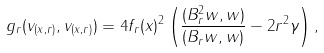Convert formula to latex. <formula><loc_0><loc_0><loc_500><loc_500>g _ { r } ( v _ { ( x , r ) } , v _ { ( x , r ) } ) = 4 f _ { r } ( x ) ^ { 2 } \left ( \frac { ( B _ { r } ^ { 2 } w , w ) } { ( B _ { r } w , w ) } - 2 r ^ { 2 } \gamma \right ) ,</formula> 